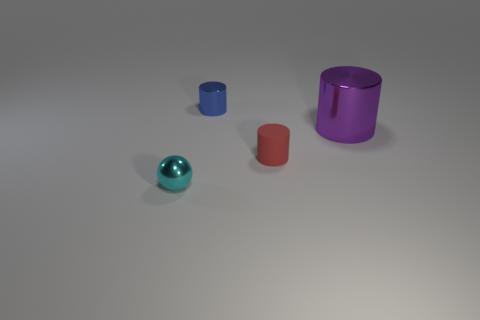Subtract all small blue metal cylinders. How many cylinders are left? 2 Add 3 red matte cylinders. How many objects exist? 7 Subtract all purple cylinders. How many cylinders are left? 2 Subtract all cylinders. How many objects are left? 1 Subtract 3 cylinders. How many cylinders are left? 0 Subtract all yellow balls. How many red cylinders are left? 1 Subtract all big gray matte objects. Subtract all large purple metal things. How many objects are left? 3 Add 1 small blue metal things. How many small blue metal things are left? 2 Add 4 small spheres. How many small spheres exist? 5 Subtract 1 red cylinders. How many objects are left? 3 